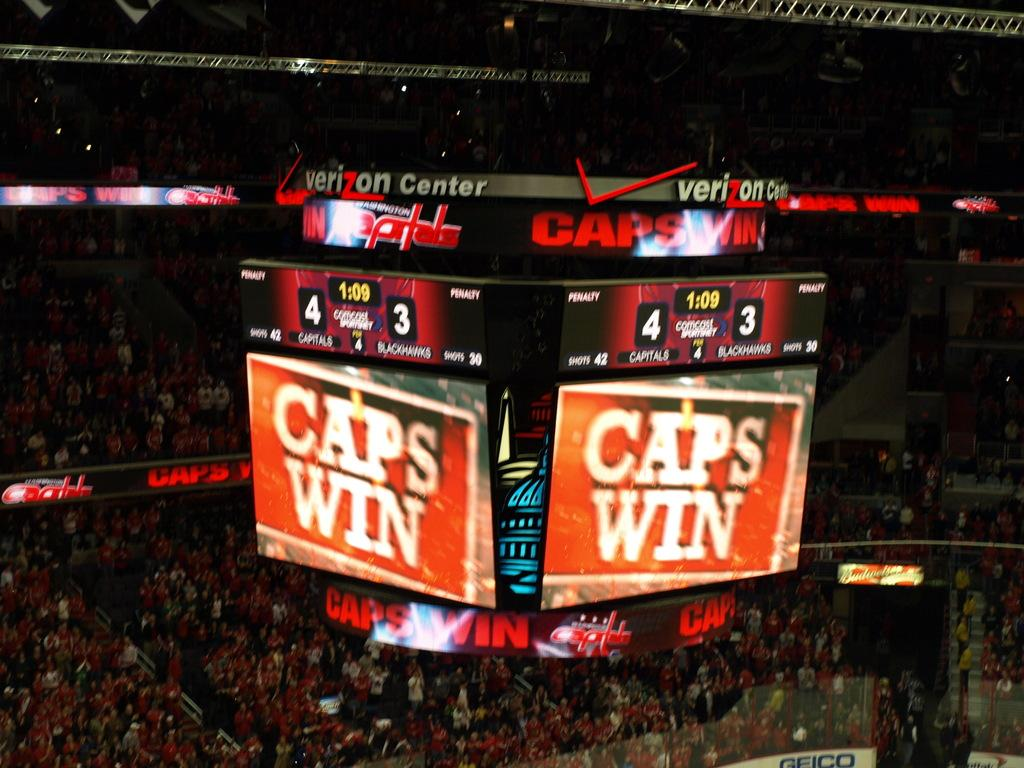<image>
Provide a brief description of the given image. A large tv screen that says CAPS WIN in big letters. 